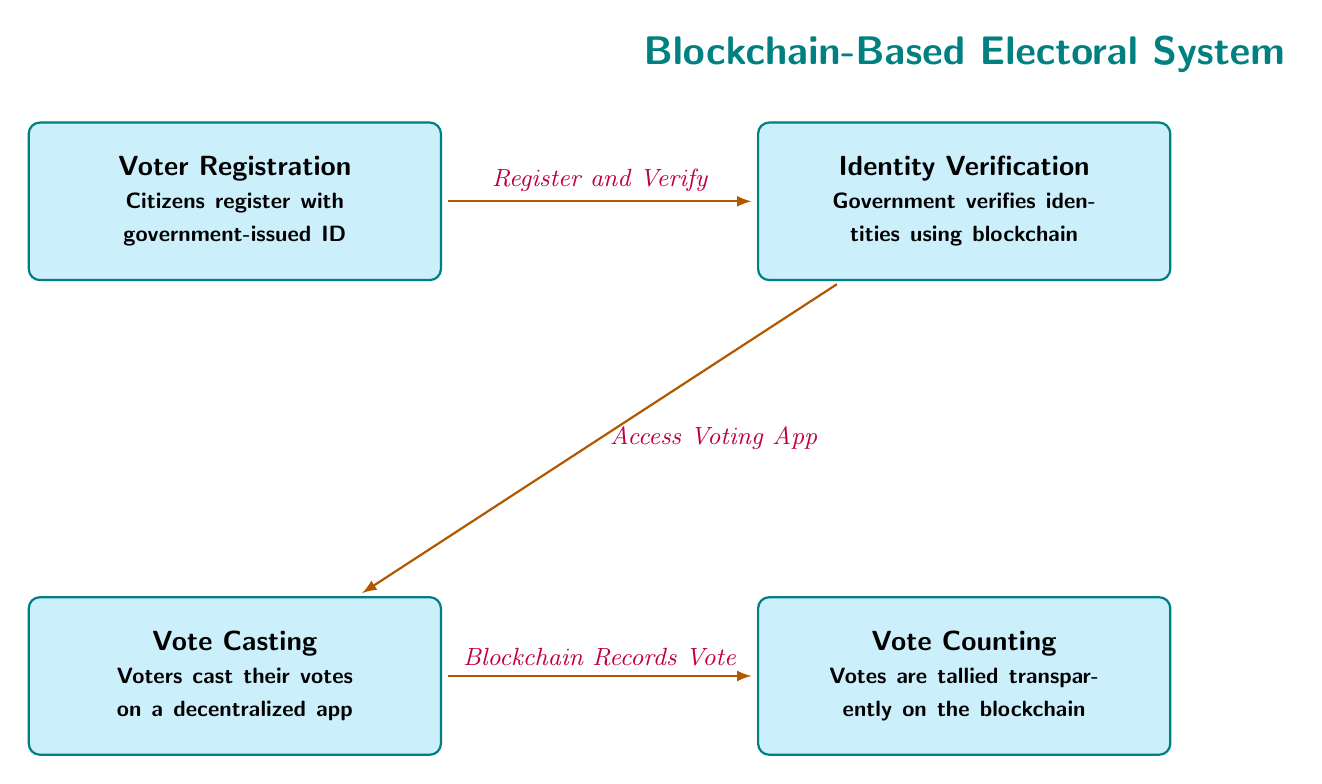What are the main steps in the blockchain-based voting process? The diagram outlines four main steps: Voter Registration, Identity Verification, Vote Casting, and Vote Counting.
Answer: Voter Registration, Identity Verification, Vote Casting, Vote Counting How many nodes are present in the diagram? Counting the four distinct actions represented in rectangles, there are four nodes: Registration, Verification, Casting, and Counting.
Answer: 4 What action occurs after Identity Verification? After Identity Verification, the next step is Vote Casting, indicating the flow of actions in the voting process.
Answer: Vote Casting What is the purpose of the Vote Counting step? The Vote Counting step tallies the votes transparently on the blockchain, showing how results are managed post-voting.
Answer: Tallies votes transparently What is required for Voter Registration? According to the diagram, citizens need a government-issued ID to register, highlighting the need for identity documentation.
Answer: Government-issued ID What connects the stages of the voting process? The stages of the voting process are connected by arrows labeled with phrases indicating the flow, such as 'Register and Verify' and 'Blockchain Records Vote'.
Answer: Arrows labeled with phrases What is the significance of using blockchain in Identity Verification? The Identity Verification process utilizes blockchain to ensure that identities are verified securely and transparently by the government.
Answer: Securely and transparently What does the Vote Casting step involve? The Vote Casting step takes place on a decentralized app, emphasizing the use of technology in the voting process.
Answer: Decentralized app 